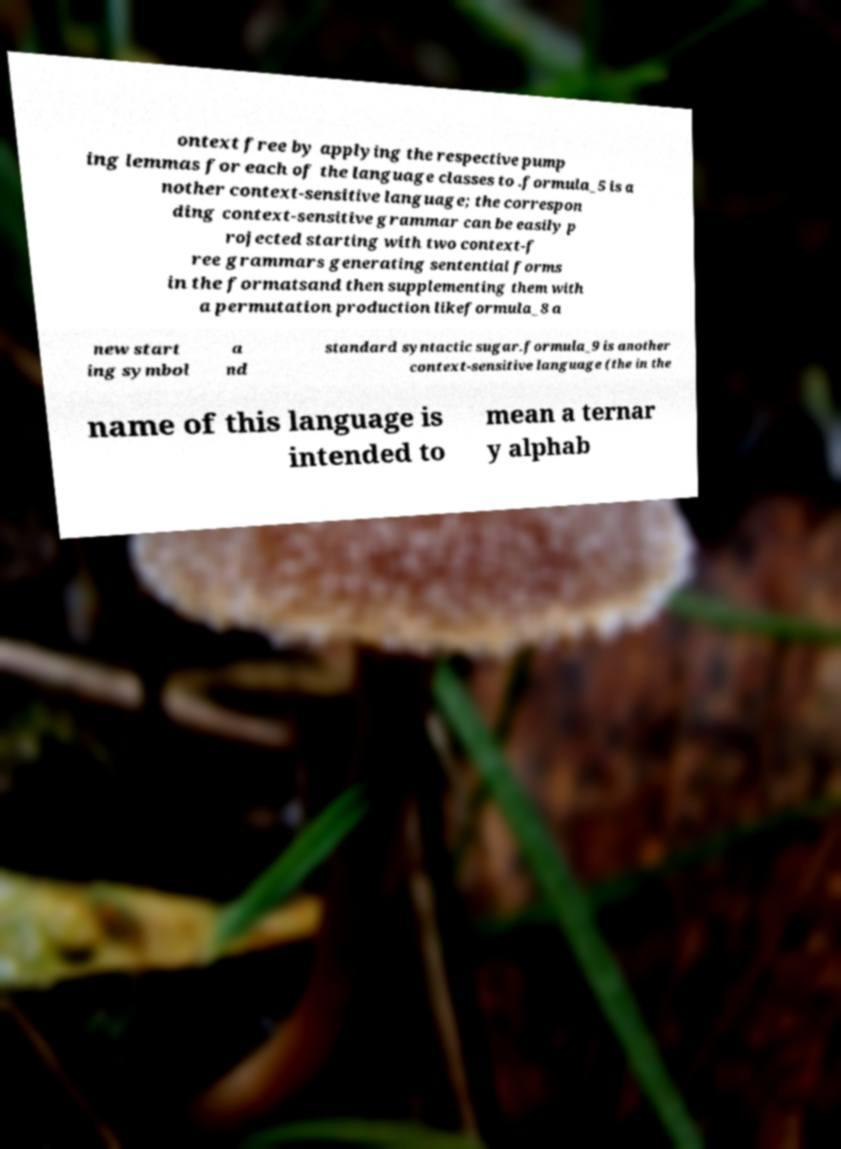For documentation purposes, I need the text within this image transcribed. Could you provide that? ontext free by applying the respective pump ing lemmas for each of the language classes to .formula_5 is a nother context-sensitive language; the correspon ding context-sensitive grammar can be easily p rojected starting with two context-f ree grammars generating sentential forms in the formatsand then supplementing them with a permutation production likeformula_8 a new start ing symbol a nd standard syntactic sugar.formula_9 is another context-sensitive language (the in the name of this language is intended to mean a ternar y alphab 